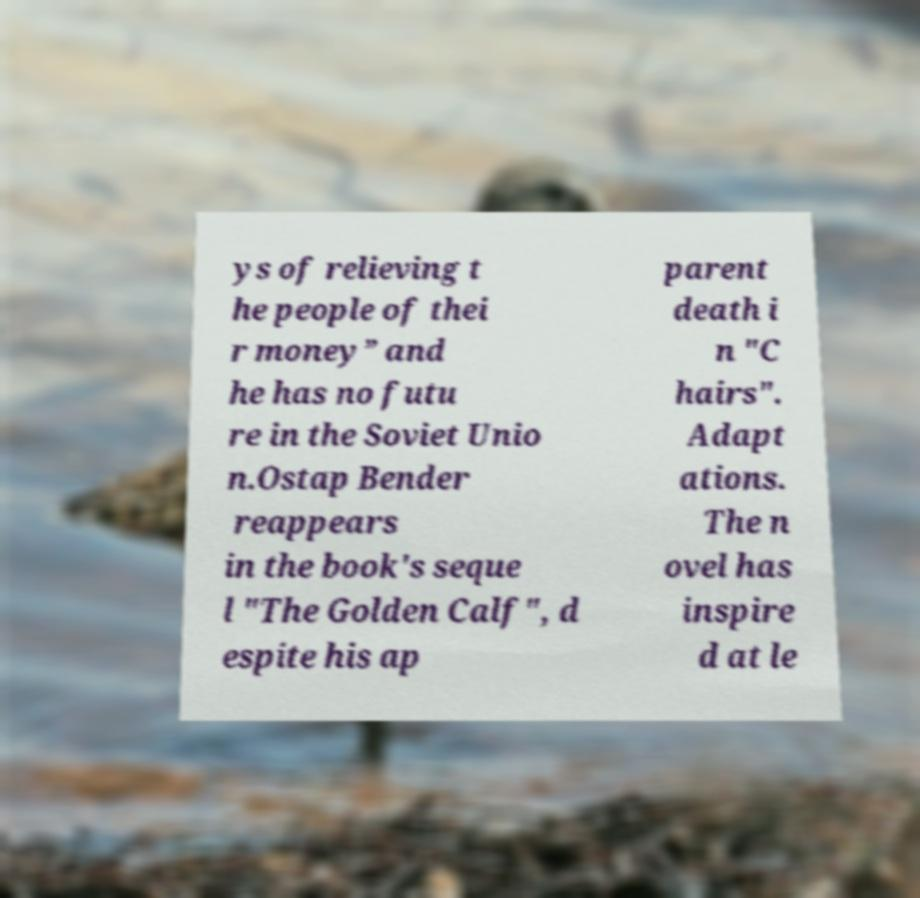Could you assist in decoding the text presented in this image and type it out clearly? ys of relieving t he people of thei r money” and he has no futu re in the Soviet Unio n.Ostap Bender reappears in the book's seque l "The Golden Calf", d espite his ap parent death i n "C hairs". Adapt ations. The n ovel has inspire d at le 